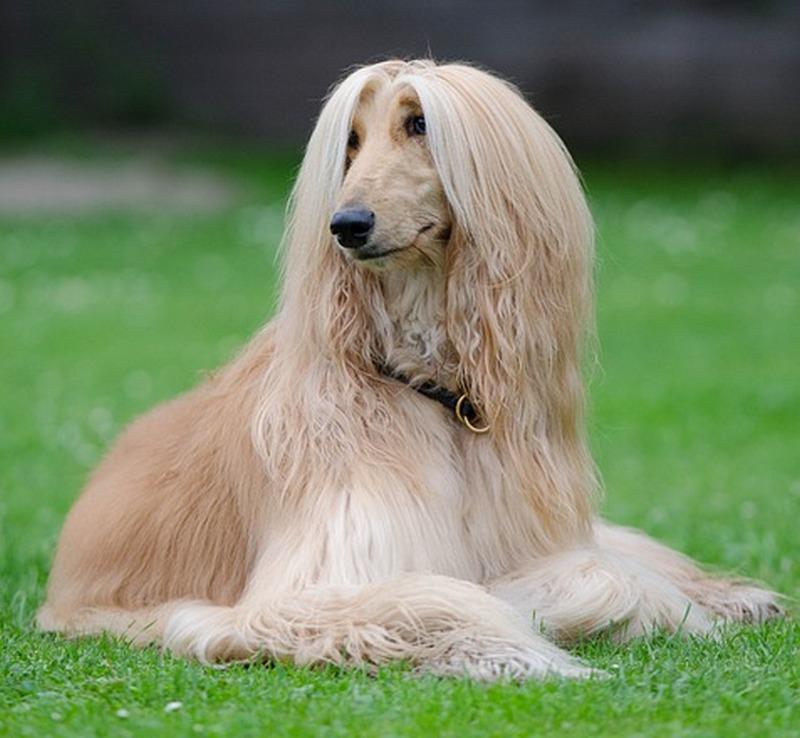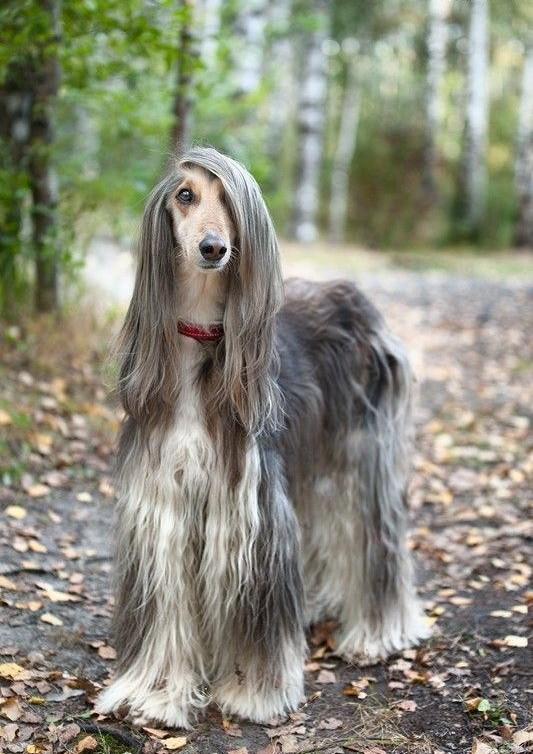The first image is the image on the left, the second image is the image on the right. Assess this claim about the two images: "One dog is standing on all fours, and the other dog is reclining with raised head and outstretched front paws on the grass.". Correct or not? Answer yes or no. Yes. 